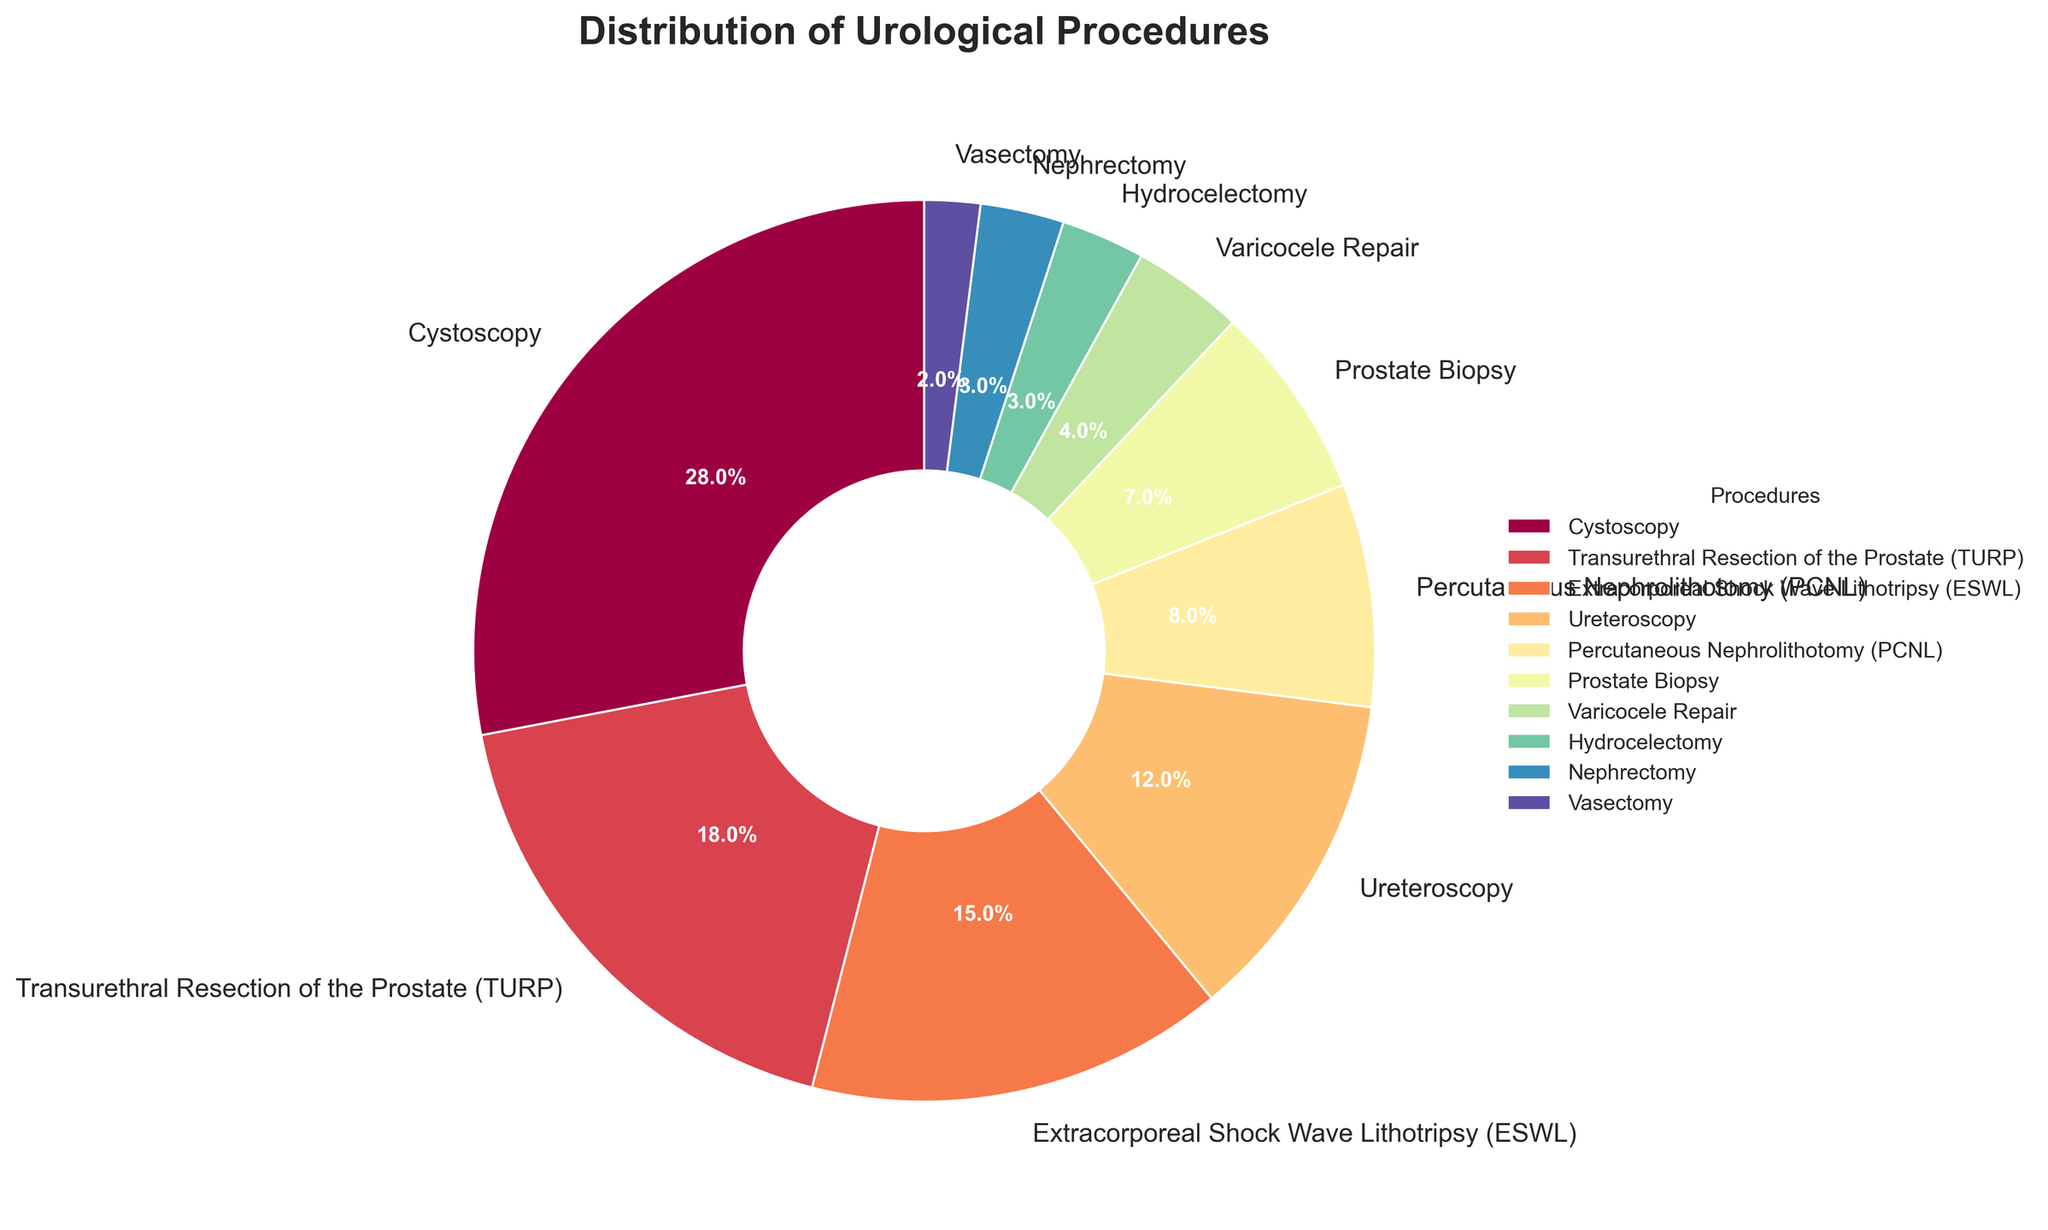Which procedure is the most commonly performed? To determine the most common procedure, look at the procedure with the largest percentage slice in the pie chart. Cystoscopy has the largest slice, accounting for 28%.
Answer: Cystoscopy What is the combined percentage of lithotripsy (ESWL) and ureteroscopy procedures? Locate the percentage of both Extracorporeal Shock Wave Lithotripsy (ESWL) and Ureteroscopy from the chart. ESWL is 15% and Ureteroscopy is 12%. Sum these percentages: 15% + 12% = 27%.
Answer: 27% How many procedures account for less than 5% each? Identify the procedures with slices smaller than 5% on the pie chart. Varicocele Repair (4%), Hydrocelectomy (3%), Nephrectomy (3%), and Vasectomy (2%) are all below 5%. Count these procedures: 4.
Answer: 4 Which is performed more frequently, Transurethral Resection of the Prostate (TURP) or Percutaneous Nephrolithotomy (PCNL)? Compare the percentages for Transurethral Resection of the Prostate (TURP) and Percutaneous Nephrolithotomy (PCNL) from the chart. TURP is 18%, while PCNL is 8%. TURP has a higher percentage.
Answer: Transurethral Resection of the Prostate (TURP) What is the percentage difference between Prostate Biopsy and Vasectomy? Find the percentages for Prostate Biopsy and Vasectomy on the pie chart. Prostate Biopsy is 7%, and Vasectomy is 2%. Calculate the difference: 7% - 2% = 5%.
Answer: 5% What is the total percentage of the top three procedures? Identify the top three procedures by percentage: Cystoscopy (28%), Transurethral Resection of the Prostate (TURP) (18%), and Extracorporeal Shock Wave Lithotripsy (ESWL) (15%). Sum these percentages: 28% + 18% + 15% = 61%.
Answer: 61% Which procedure has the smallest slice on the pie chart? Locate the procedure with the smallest percentage slice. Vasectomy has the smallest slice, accounting for 2%.
Answer: Vasectomy Is the percentage of Hydrocelectomy higher or lower than Nephrectomy? Compare the percentages of Hydrocelectomy (3%) and Nephrectomy (3%). Both procedures have equal percentages of 3%.
Answer: Equal Would you consider lithotripsy a common procedure in this hospital setting? Given that Extracorporeal Shock Wave Lithotripsy (ESWL) accounts for 15% of the procedures, which places it among the top four. This indicates it's a relatively common procedure.
Answer: Yes What is the difference in percentage between the most common and the least common procedures? Determine the percentages for Cystoscopy (most common, 28%) and Vasectomy (least common, 2%). Calculate the difference: 28% - 2% = 26%.
Answer: 26% 